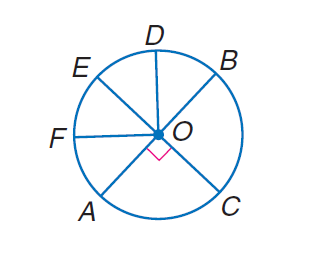Answer the mathemtical geometry problem and directly provide the correct option letter.
Question: In \odot O, E C and A B are diameters, and \angle B O D \cong \angle D O E \cong \angle E O F \cong \angle F O A. Find m \widehat A D C.
Choices: A: 90 B: 135 C: 180 D: 270 D 